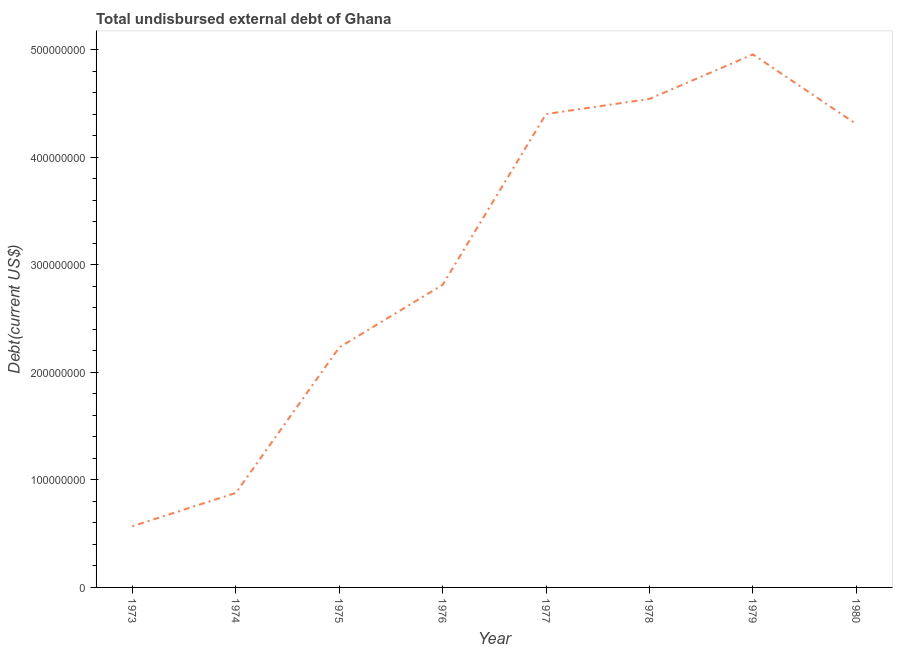What is the total debt in 1973?
Your answer should be compact. 5.69e+07. Across all years, what is the maximum total debt?
Ensure brevity in your answer.  4.96e+08. Across all years, what is the minimum total debt?
Offer a terse response. 5.69e+07. In which year was the total debt maximum?
Your answer should be compact. 1979. In which year was the total debt minimum?
Make the answer very short. 1973. What is the sum of the total debt?
Your response must be concise. 2.47e+09. What is the difference between the total debt in 1976 and 1977?
Make the answer very short. -1.59e+08. What is the average total debt per year?
Keep it short and to the point. 3.09e+08. What is the median total debt?
Give a very brief answer. 3.56e+08. Do a majority of the years between 1979 and 1980 (inclusive) have total debt greater than 240000000 US$?
Make the answer very short. Yes. What is the ratio of the total debt in 1973 to that in 1980?
Offer a very short reply. 0.13. Is the total debt in 1975 less than that in 1976?
Ensure brevity in your answer.  Yes. Is the difference between the total debt in 1976 and 1977 greater than the difference between any two years?
Offer a terse response. No. What is the difference between the highest and the second highest total debt?
Provide a succinct answer. 4.14e+07. What is the difference between the highest and the lowest total debt?
Provide a succinct answer. 4.39e+08. In how many years, is the total debt greater than the average total debt taken over all years?
Your answer should be very brief. 4. Does the total debt monotonically increase over the years?
Offer a very short reply. No. Are the values on the major ticks of Y-axis written in scientific E-notation?
Your response must be concise. No. Does the graph contain any zero values?
Offer a very short reply. No. Does the graph contain grids?
Offer a terse response. No. What is the title of the graph?
Your answer should be very brief. Total undisbursed external debt of Ghana. What is the label or title of the Y-axis?
Offer a terse response. Debt(current US$). What is the Debt(current US$) of 1973?
Your answer should be very brief. 5.69e+07. What is the Debt(current US$) in 1974?
Provide a succinct answer. 8.79e+07. What is the Debt(current US$) in 1975?
Keep it short and to the point. 2.23e+08. What is the Debt(current US$) in 1976?
Give a very brief answer. 2.82e+08. What is the Debt(current US$) of 1977?
Your answer should be very brief. 4.40e+08. What is the Debt(current US$) of 1978?
Your answer should be compact. 4.54e+08. What is the Debt(current US$) in 1979?
Offer a terse response. 4.96e+08. What is the Debt(current US$) of 1980?
Provide a short and direct response. 4.31e+08. What is the difference between the Debt(current US$) in 1973 and 1974?
Make the answer very short. -3.10e+07. What is the difference between the Debt(current US$) in 1973 and 1975?
Your answer should be compact. -1.66e+08. What is the difference between the Debt(current US$) in 1973 and 1976?
Ensure brevity in your answer.  -2.25e+08. What is the difference between the Debt(current US$) in 1973 and 1977?
Your answer should be compact. -3.83e+08. What is the difference between the Debt(current US$) in 1973 and 1978?
Keep it short and to the point. -3.98e+08. What is the difference between the Debt(current US$) in 1973 and 1979?
Keep it short and to the point. -4.39e+08. What is the difference between the Debt(current US$) in 1973 and 1980?
Make the answer very short. -3.74e+08. What is the difference between the Debt(current US$) in 1974 and 1975?
Provide a short and direct response. -1.35e+08. What is the difference between the Debt(current US$) in 1974 and 1976?
Provide a succinct answer. -1.94e+08. What is the difference between the Debt(current US$) in 1974 and 1977?
Make the answer very short. -3.53e+08. What is the difference between the Debt(current US$) in 1974 and 1978?
Offer a terse response. -3.67e+08. What is the difference between the Debt(current US$) in 1974 and 1979?
Offer a terse response. -4.08e+08. What is the difference between the Debt(current US$) in 1974 and 1980?
Your answer should be very brief. -3.43e+08. What is the difference between the Debt(current US$) in 1975 and 1976?
Make the answer very short. -5.83e+07. What is the difference between the Debt(current US$) in 1975 and 1977?
Keep it short and to the point. -2.17e+08. What is the difference between the Debt(current US$) in 1975 and 1978?
Your answer should be very brief. -2.31e+08. What is the difference between the Debt(current US$) in 1975 and 1979?
Provide a short and direct response. -2.73e+08. What is the difference between the Debt(current US$) in 1975 and 1980?
Provide a succinct answer. -2.08e+08. What is the difference between the Debt(current US$) in 1976 and 1977?
Make the answer very short. -1.59e+08. What is the difference between the Debt(current US$) in 1976 and 1978?
Your answer should be very brief. -1.73e+08. What is the difference between the Debt(current US$) in 1976 and 1979?
Offer a terse response. -2.14e+08. What is the difference between the Debt(current US$) in 1976 and 1980?
Your response must be concise. -1.50e+08. What is the difference between the Debt(current US$) in 1977 and 1978?
Your response must be concise. -1.41e+07. What is the difference between the Debt(current US$) in 1977 and 1979?
Offer a very short reply. -5.55e+07. What is the difference between the Debt(current US$) in 1977 and 1980?
Offer a very short reply. 9.33e+06. What is the difference between the Debt(current US$) in 1978 and 1979?
Provide a succinct answer. -4.14e+07. What is the difference between the Debt(current US$) in 1978 and 1980?
Your answer should be compact. 2.34e+07. What is the difference between the Debt(current US$) in 1979 and 1980?
Ensure brevity in your answer.  6.48e+07. What is the ratio of the Debt(current US$) in 1973 to that in 1974?
Your answer should be very brief. 0.65. What is the ratio of the Debt(current US$) in 1973 to that in 1975?
Offer a very short reply. 0.26. What is the ratio of the Debt(current US$) in 1973 to that in 1976?
Give a very brief answer. 0.2. What is the ratio of the Debt(current US$) in 1973 to that in 1977?
Provide a succinct answer. 0.13. What is the ratio of the Debt(current US$) in 1973 to that in 1978?
Your answer should be compact. 0.12. What is the ratio of the Debt(current US$) in 1973 to that in 1979?
Your answer should be compact. 0.12. What is the ratio of the Debt(current US$) in 1973 to that in 1980?
Ensure brevity in your answer.  0.13. What is the ratio of the Debt(current US$) in 1974 to that in 1975?
Give a very brief answer. 0.39. What is the ratio of the Debt(current US$) in 1974 to that in 1976?
Your response must be concise. 0.31. What is the ratio of the Debt(current US$) in 1974 to that in 1978?
Keep it short and to the point. 0.19. What is the ratio of the Debt(current US$) in 1974 to that in 1979?
Offer a very short reply. 0.18. What is the ratio of the Debt(current US$) in 1974 to that in 1980?
Your response must be concise. 0.2. What is the ratio of the Debt(current US$) in 1975 to that in 1976?
Provide a succinct answer. 0.79. What is the ratio of the Debt(current US$) in 1975 to that in 1977?
Your answer should be compact. 0.51. What is the ratio of the Debt(current US$) in 1975 to that in 1978?
Offer a very short reply. 0.49. What is the ratio of the Debt(current US$) in 1975 to that in 1979?
Provide a short and direct response. 0.45. What is the ratio of the Debt(current US$) in 1975 to that in 1980?
Offer a very short reply. 0.52. What is the ratio of the Debt(current US$) in 1976 to that in 1977?
Your response must be concise. 0.64. What is the ratio of the Debt(current US$) in 1976 to that in 1978?
Your answer should be compact. 0.62. What is the ratio of the Debt(current US$) in 1976 to that in 1979?
Offer a terse response. 0.57. What is the ratio of the Debt(current US$) in 1976 to that in 1980?
Provide a succinct answer. 0.65. What is the ratio of the Debt(current US$) in 1977 to that in 1978?
Give a very brief answer. 0.97. What is the ratio of the Debt(current US$) in 1977 to that in 1979?
Provide a succinct answer. 0.89. What is the ratio of the Debt(current US$) in 1977 to that in 1980?
Offer a very short reply. 1.02. What is the ratio of the Debt(current US$) in 1978 to that in 1979?
Make the answer very short. 0.92. What is the ratio of the Debt(current US$) in 1978 to that in 1980?
Give a very brief answer. 1.05. What is the ratio of the Debt(current US$) in 1979 to that in 1980?
Your response must be concise. 1.15. 